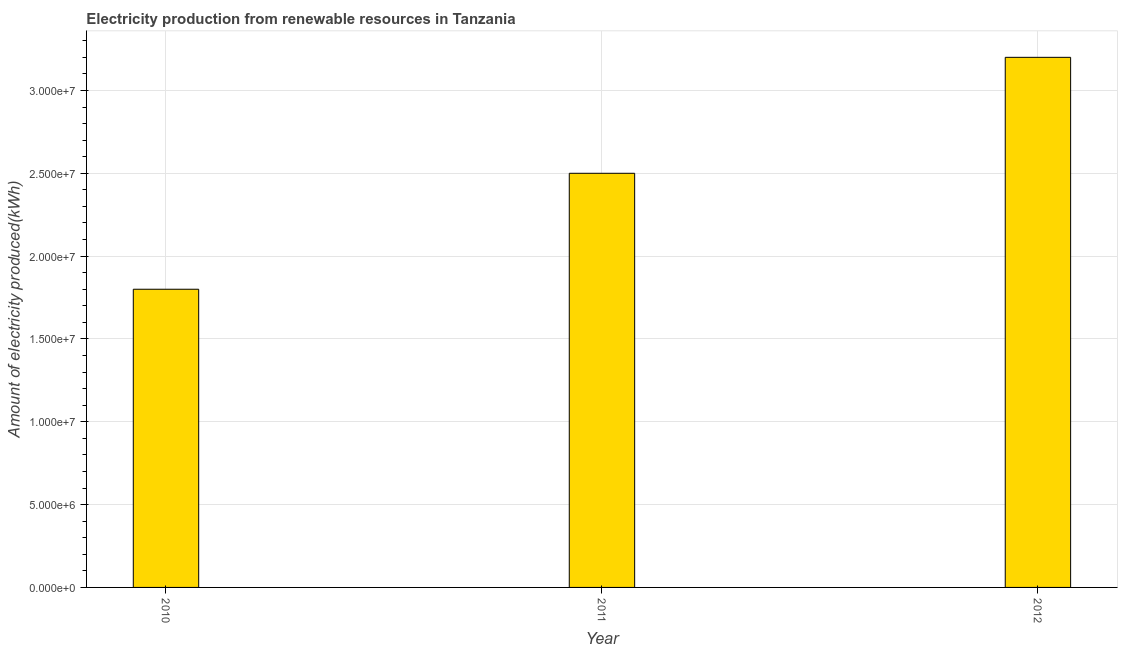Does the graph contain grids?
Your answer should be very brief. Yes. What is the title of the graph?
Keep it short and to the point. Electricity production from renewable resources in Tanzania. What is the label or title of the Y-axis?
Make the answer very short. Amount of electricity produced(kWh). What is the amount of electricity produced in 2011?
Your answer should be compact. 2.50e+07. Across all years, what is the maximum amount of electricity produced?
Give a very brief answer. 3.20e+07. Across all years, what is the minimum amount of electricity produced?
Ensure brevity in your answer.  1.80e+07. In which year was the amount of electricity produced minimum?
Offer a very short reply. 2010. What is the sum of the amount of electricity produced?
Offer a terse response. 7.50e+07. What is the difference between the amount of electricity produced in 2010 and 2011?
Provide a short and direct response. -7.00e+06. What is the average amount of electricity produced per year?
Make the answer very short. 2.50e+07. What is the median amount of electricity produced?
Offer a terse response. 2.50e+07. Do a majority of the years between 2011 and 2010 (inclusive) have amount of electricity produced greater than 7000000 kWh?
Give a very brief answer. No. What is the ratio of the amount of electricity produced in 2011 to that in 2012?
Provide a succinct answer. 0.78. Is the difference between the amount of electricity produced in 2010 and 2011 greater than the difference between any two years?
Give a very brief answer. No. What is the difference between the highest and the second highest amount of electricity produced?
Offer a very short reply. 7.00e+06. What is the difference between the highest and the lowest amount of electricity produced?
Your answer should be compact. 1.40e+07. Are all the bars in the graph horizontal?
Your answer should be very brief. No. What is the Amount of electricity produced(kWh) of 2010?
Offer a terse response. 1.80e+07. What is the Amount of electricity produced(kWh) of 2011?
Your response must be concise. 2.50e+07. What is the Amount of electricity produced(kWh) in 2012?
Keep it short and to the point. 3.20e+07. What is the difference between the Amount of electricity produced(kWh) in 2010 and 2011?
Provide a succinct answer. -7.00e+06. What is the difference between the Amount of electricity produced(kWh) in 2010 and 2012?
Your answer should be very brief. -1.40e+07. What is the difference between the Amount of electricity produced(kWh) in 2011 and 2012?
Offer a very short reply. -7.00e+06. What is the ratio of the Amount of electricity produced(kWh) in 2010 to that in 2011?
Your answer should be very brief. 0.72. What is the ratio of the Amount of electricity produced(kWh) in 2010 to that in 2012?
Offer a terse response. 0.56. What is the ratio of the Amount of electricity produced(kWh) in 2011 to that in 2012?
Ensure brevity in your answer.  0.78. 